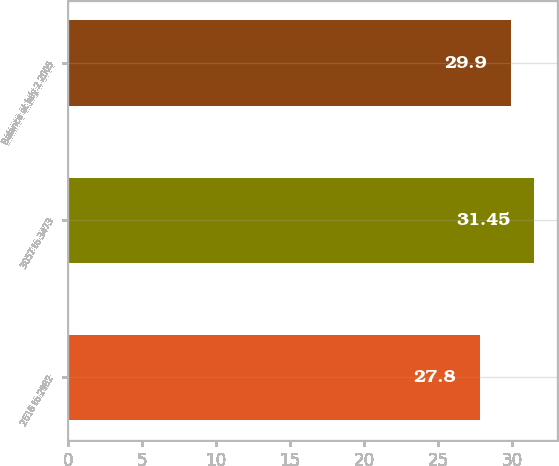Convert chart to OTSL. <chart><loc_0><loc_0><loc_500><loc_500><bar_chart><fcel>2616 to 2982<fcel>3057 to 3473<fcel>Balance at July 2 2005<nl><fcel>27.8<fcel>31.45<fcel>29.9<nl></chart> 